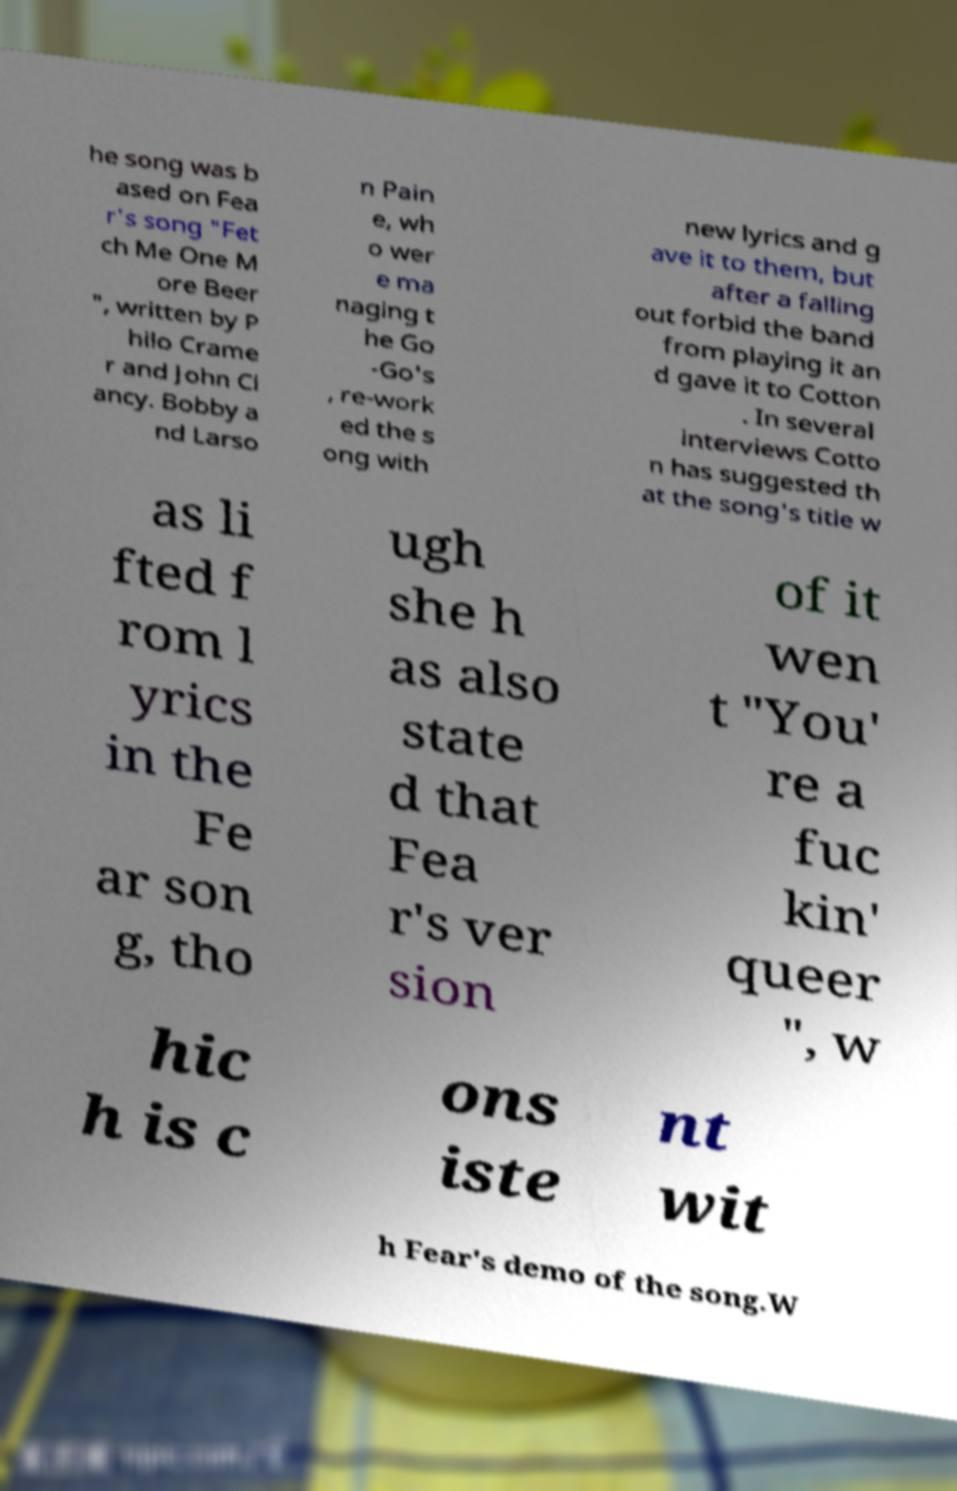Can you accurately transcribe the text from the provided image for me? he song was b ased on Fea r's song "Fet ch Me One M ore Beer ", written by P hilo Crame r and John Cl ancy. Bobby a nd Larso n Pain e, wh o wer e ma naging t he Go -Go's , re-work ed the s ong with new lyrics and g ave it to them, but after a falling out forbid the band from playing it an d gave it to Cotton . In several interviews Cotto n has suggested th at the song's title w as li fted f rom l yrics in the Fe ar son g, tho ugh she h as also state d that Fea r's ver sion of it wen t "You' re a fuc kin' queer ", w hic h is c ons iste nt wit h Fear's demo of the song.W 